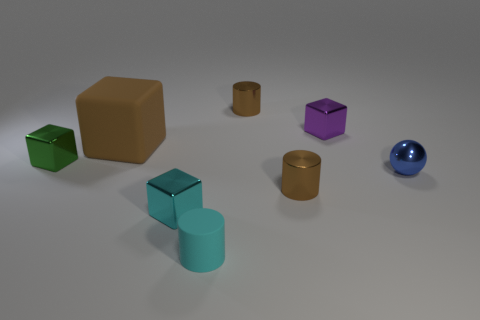Add 1 small brown shiny cylinders. How many objects exist? 9 Subtract all spheres. How many objects are left? 7 Add 4 blue balls. How many blue balls are left? 5 Add 2 tiny cyan objects. How many tiny cyan objects exist? 4 Subtract 0 yellow spheres. How many objects are left? 8 Subtract all tiny purple objects. Subtract all large yellow metallic cubes. How many objects are left? 7 